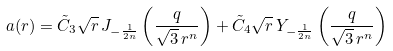<formula> <loc_0><loc_0><loc_500><loc_500>a ( r ) = \tilde { C } _ { 3 } \sqrt { r } \, J _ { - \frac { 1 } { 2 n } } \left ( \frac { q } { \sqrt { 3 } \, r ^ { n } } \right ) + \tilde { C } _ { 4 } \sqrt { r } \, Y _ { - \frac { 1 } { 2 n } } \left ( \frac { q } { \sqrt { 3 } \, r ^ { n } } \right )</formula> 